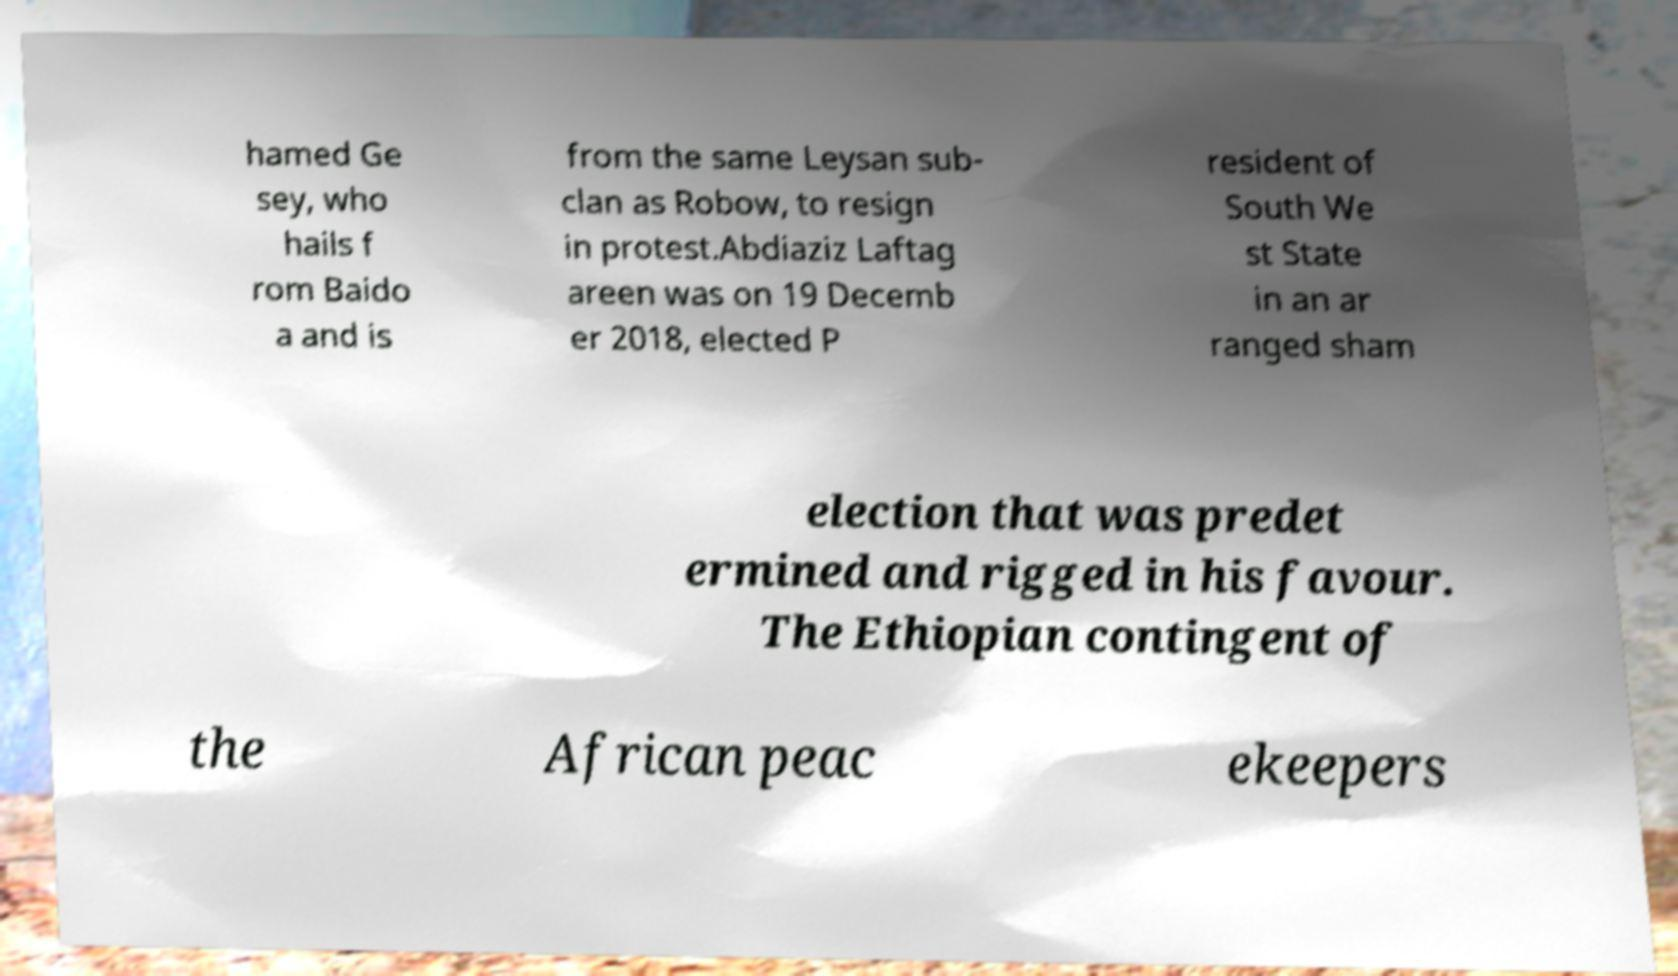There's text embedded in this image that I need extracted. Can you transcribe it verbatim? hamed Ge sey, who hails f rom Baido a and is from the same Leysan sub- clan as Robow, to resign in protest.Abdiaziz Laftag areen was on 19 Decemb er 2018, elected P resident of South We st State in an ar ranged sham election that was predet ermined and rigged in his favour. The Ethiopian contingent of the African peac ekeepers 